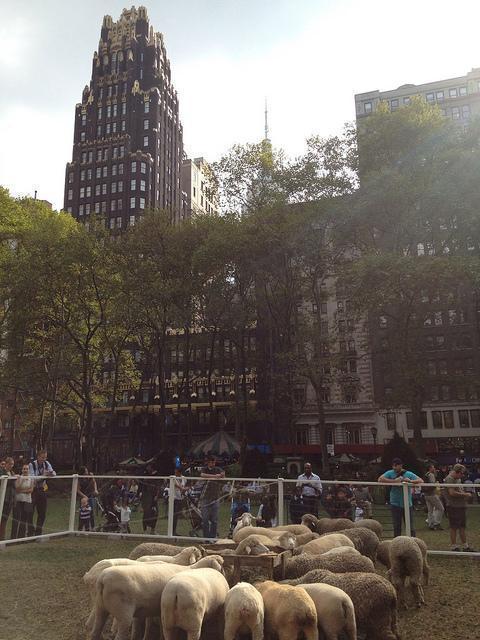What structure surrounds the animals?
Indicate the correct choice and explain in the format: 'Answer: answer
Rationale: rationale.'
Options: Barn, pen, dome, cage. Answer: pen.
Rationale: The animals surround the pen so they can feed. 